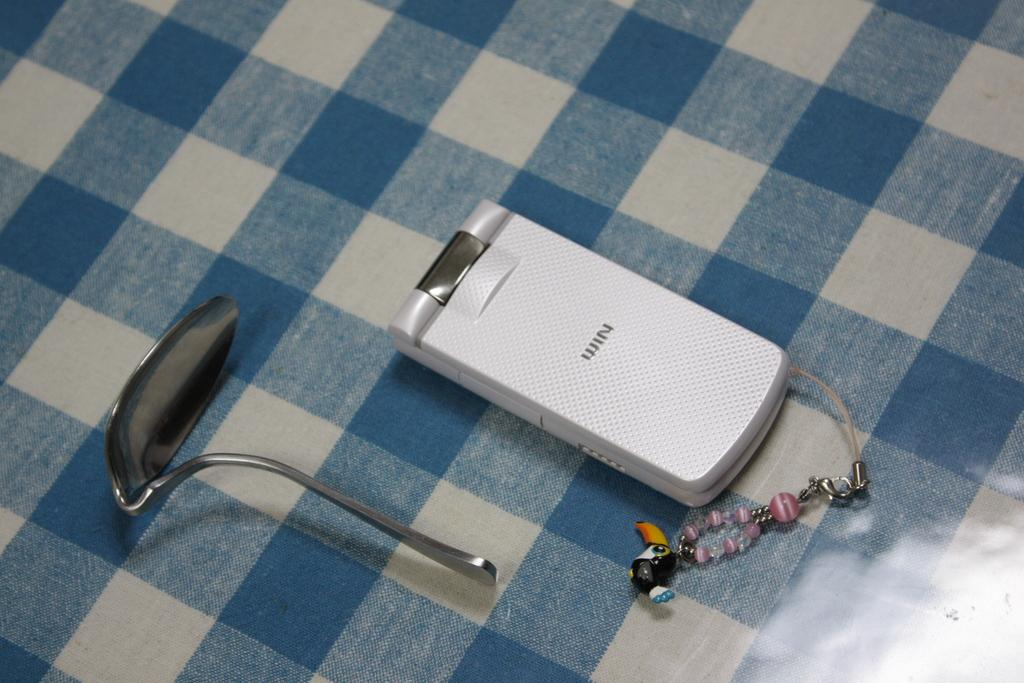Provide a one-sentence caption for the provided image. A white cell phone with the word "Win" engraved on it sits next to a bent spoon. 